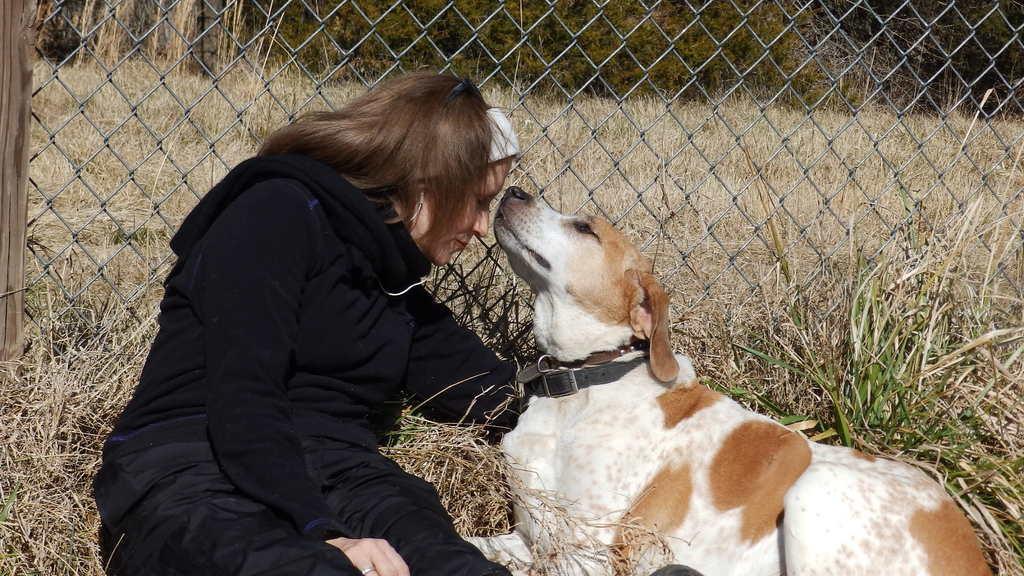Describe this image in one or two sentences. This image is clicked outside. There is a woman in black dress. In front of her there is a dog, to which a black belt is tied. In the background, there is a dry grass and trees. 